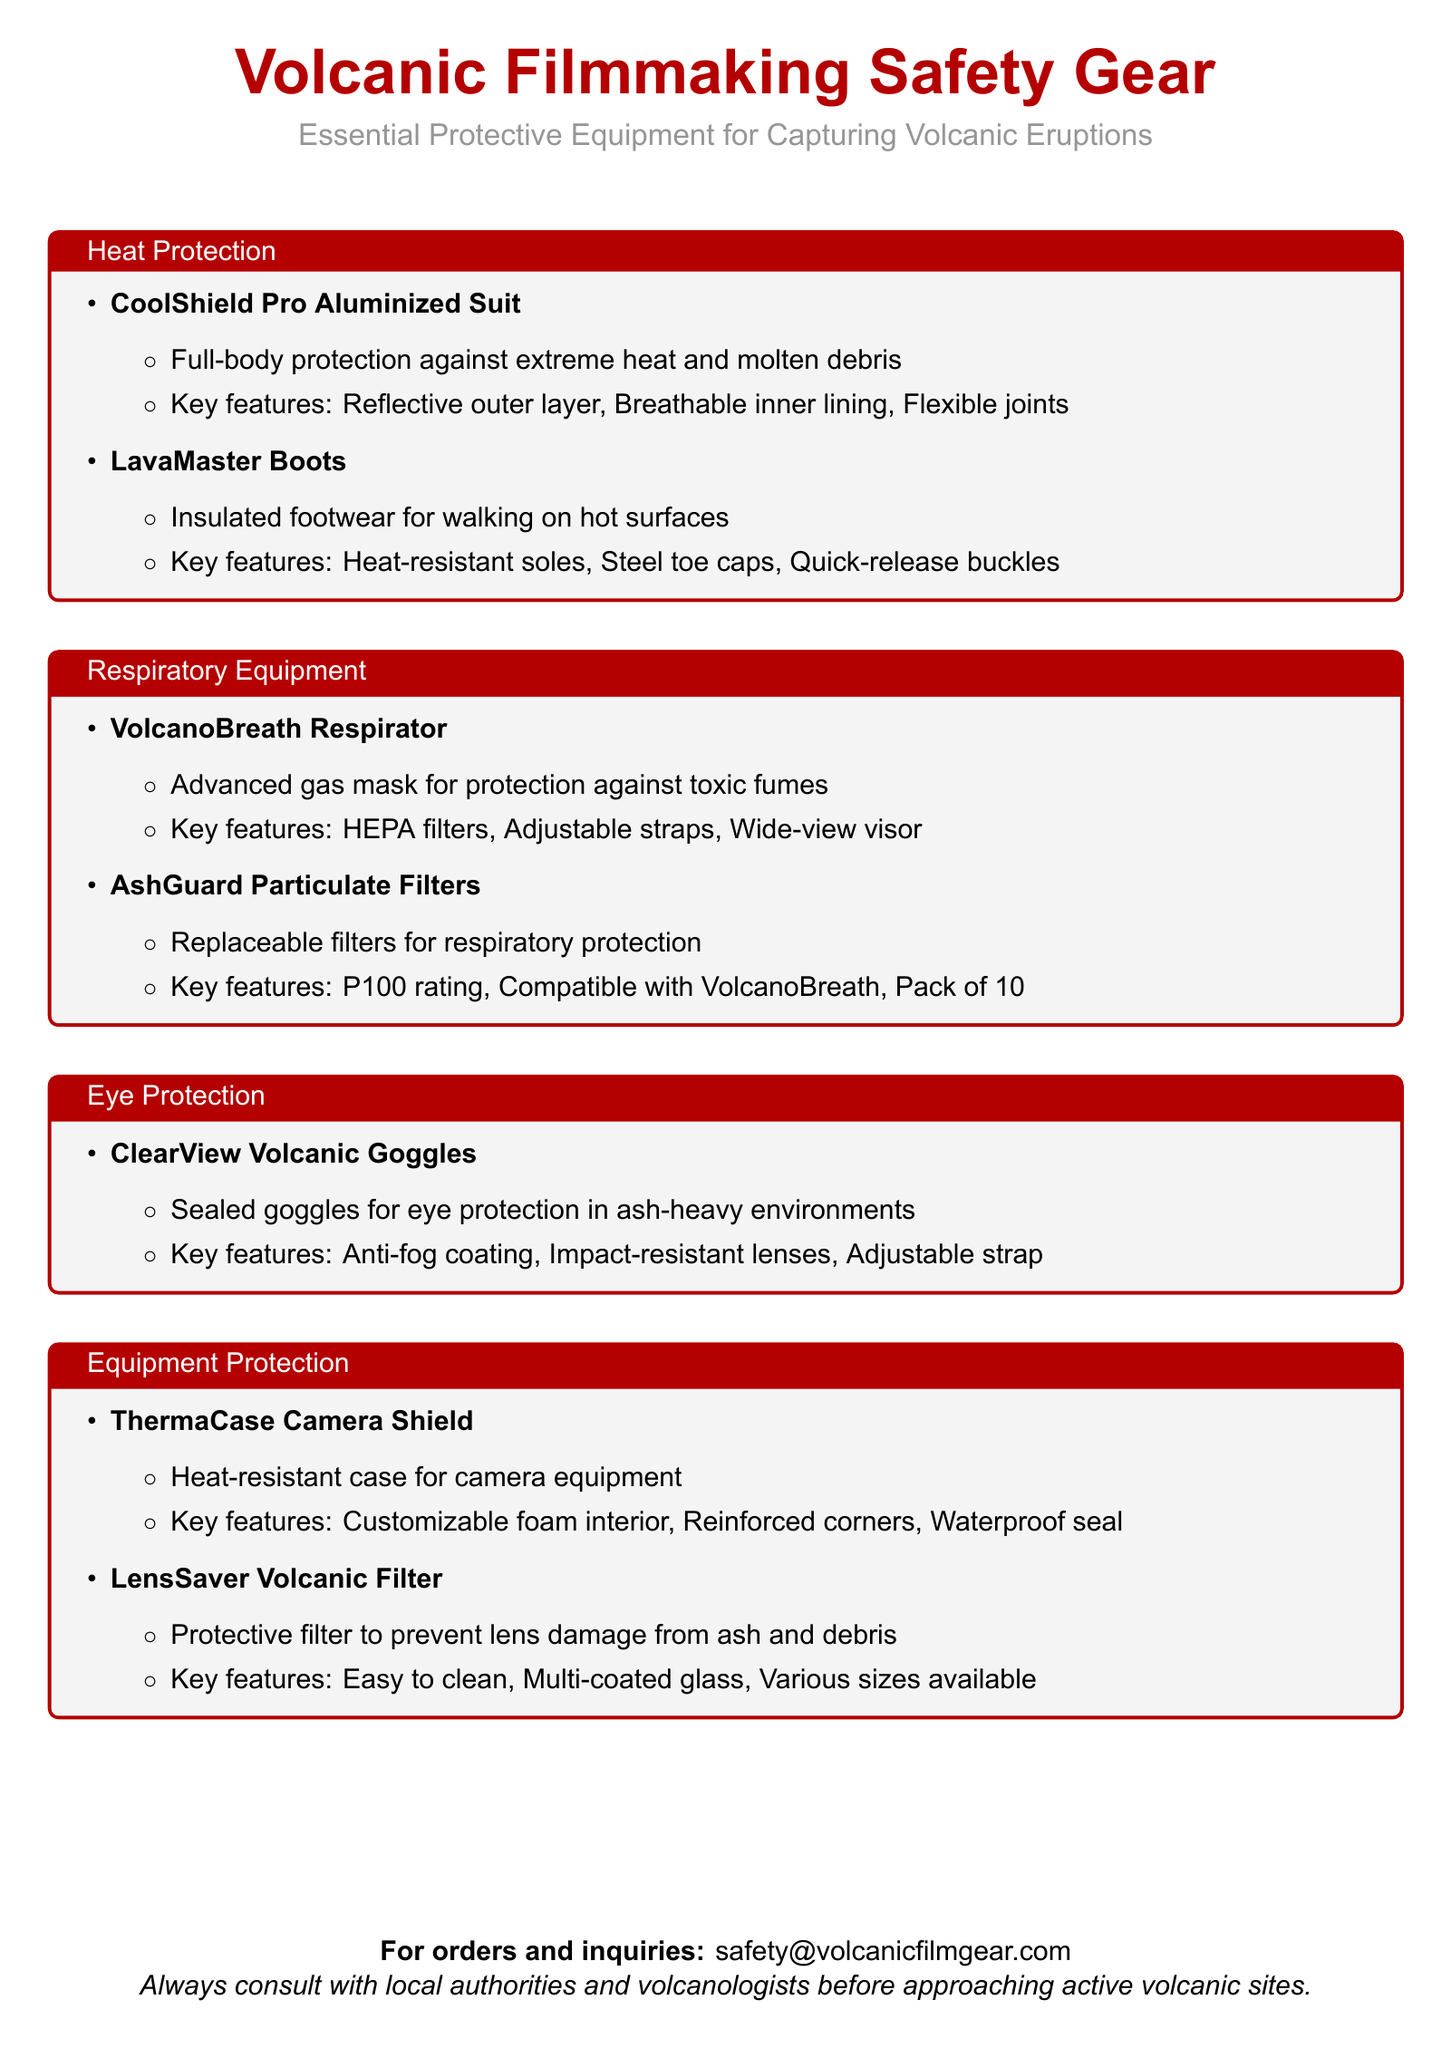What is the name of the heat protection suit? The document lists the CoolShield Pro Aluminized Suit as the heat protection suit for volcanic filmmaking.
Answer: CoolShield Pro Aluminized Suit What feature allows the LavaMaster Boots to be used on hot surfaces? The document states that the LavaMaster Boots have heat-resistant soles that enable walking on hot surfaces.
Answer: Heat-resistant soles What type of respiratory equipment is mentioned? The document specifies the VolcanoBreath Respirator as a type of respiratory equipment for capturing volcanic eruptions.
Answer: VolcanoBreath Respirator How many AshGuard Particulate Filters are included in a pack? According to the document, a pack of AshGuard Particulate Filters contains 10 filters.
Answer: 10 What protective feature do ClearView Volcanic Goggles offer? The document mentions that ClearView Volcanic Goggles provide sealed eye protection in ash-heavy environments.
Answer: Sealed eye protection What is the purpose of the ThermaCase Camera Shield? The document describes the ThermaCase Camera Shield as a heat-resistant case designed for protecting camera equipment.
Answer: Heat-resistant case Which item is designed to protect camera lenses from ash? The LensSaver Volcanic Filter is specifically mentioned in the document as protecting lenses from damage caused by ash and debris.
Answer: LensSaver Volcanic Filter What should filmmakers do before approaching active volcanic sites? The document advises consulting with local authorities and volcanologists prior to approaching active volcanic sites.
Answer: Consult with local authorities What color is used for the section titles in the document? The section titles in the document are highlighted using the color volcanoRed.
Answer: volcanoRed 